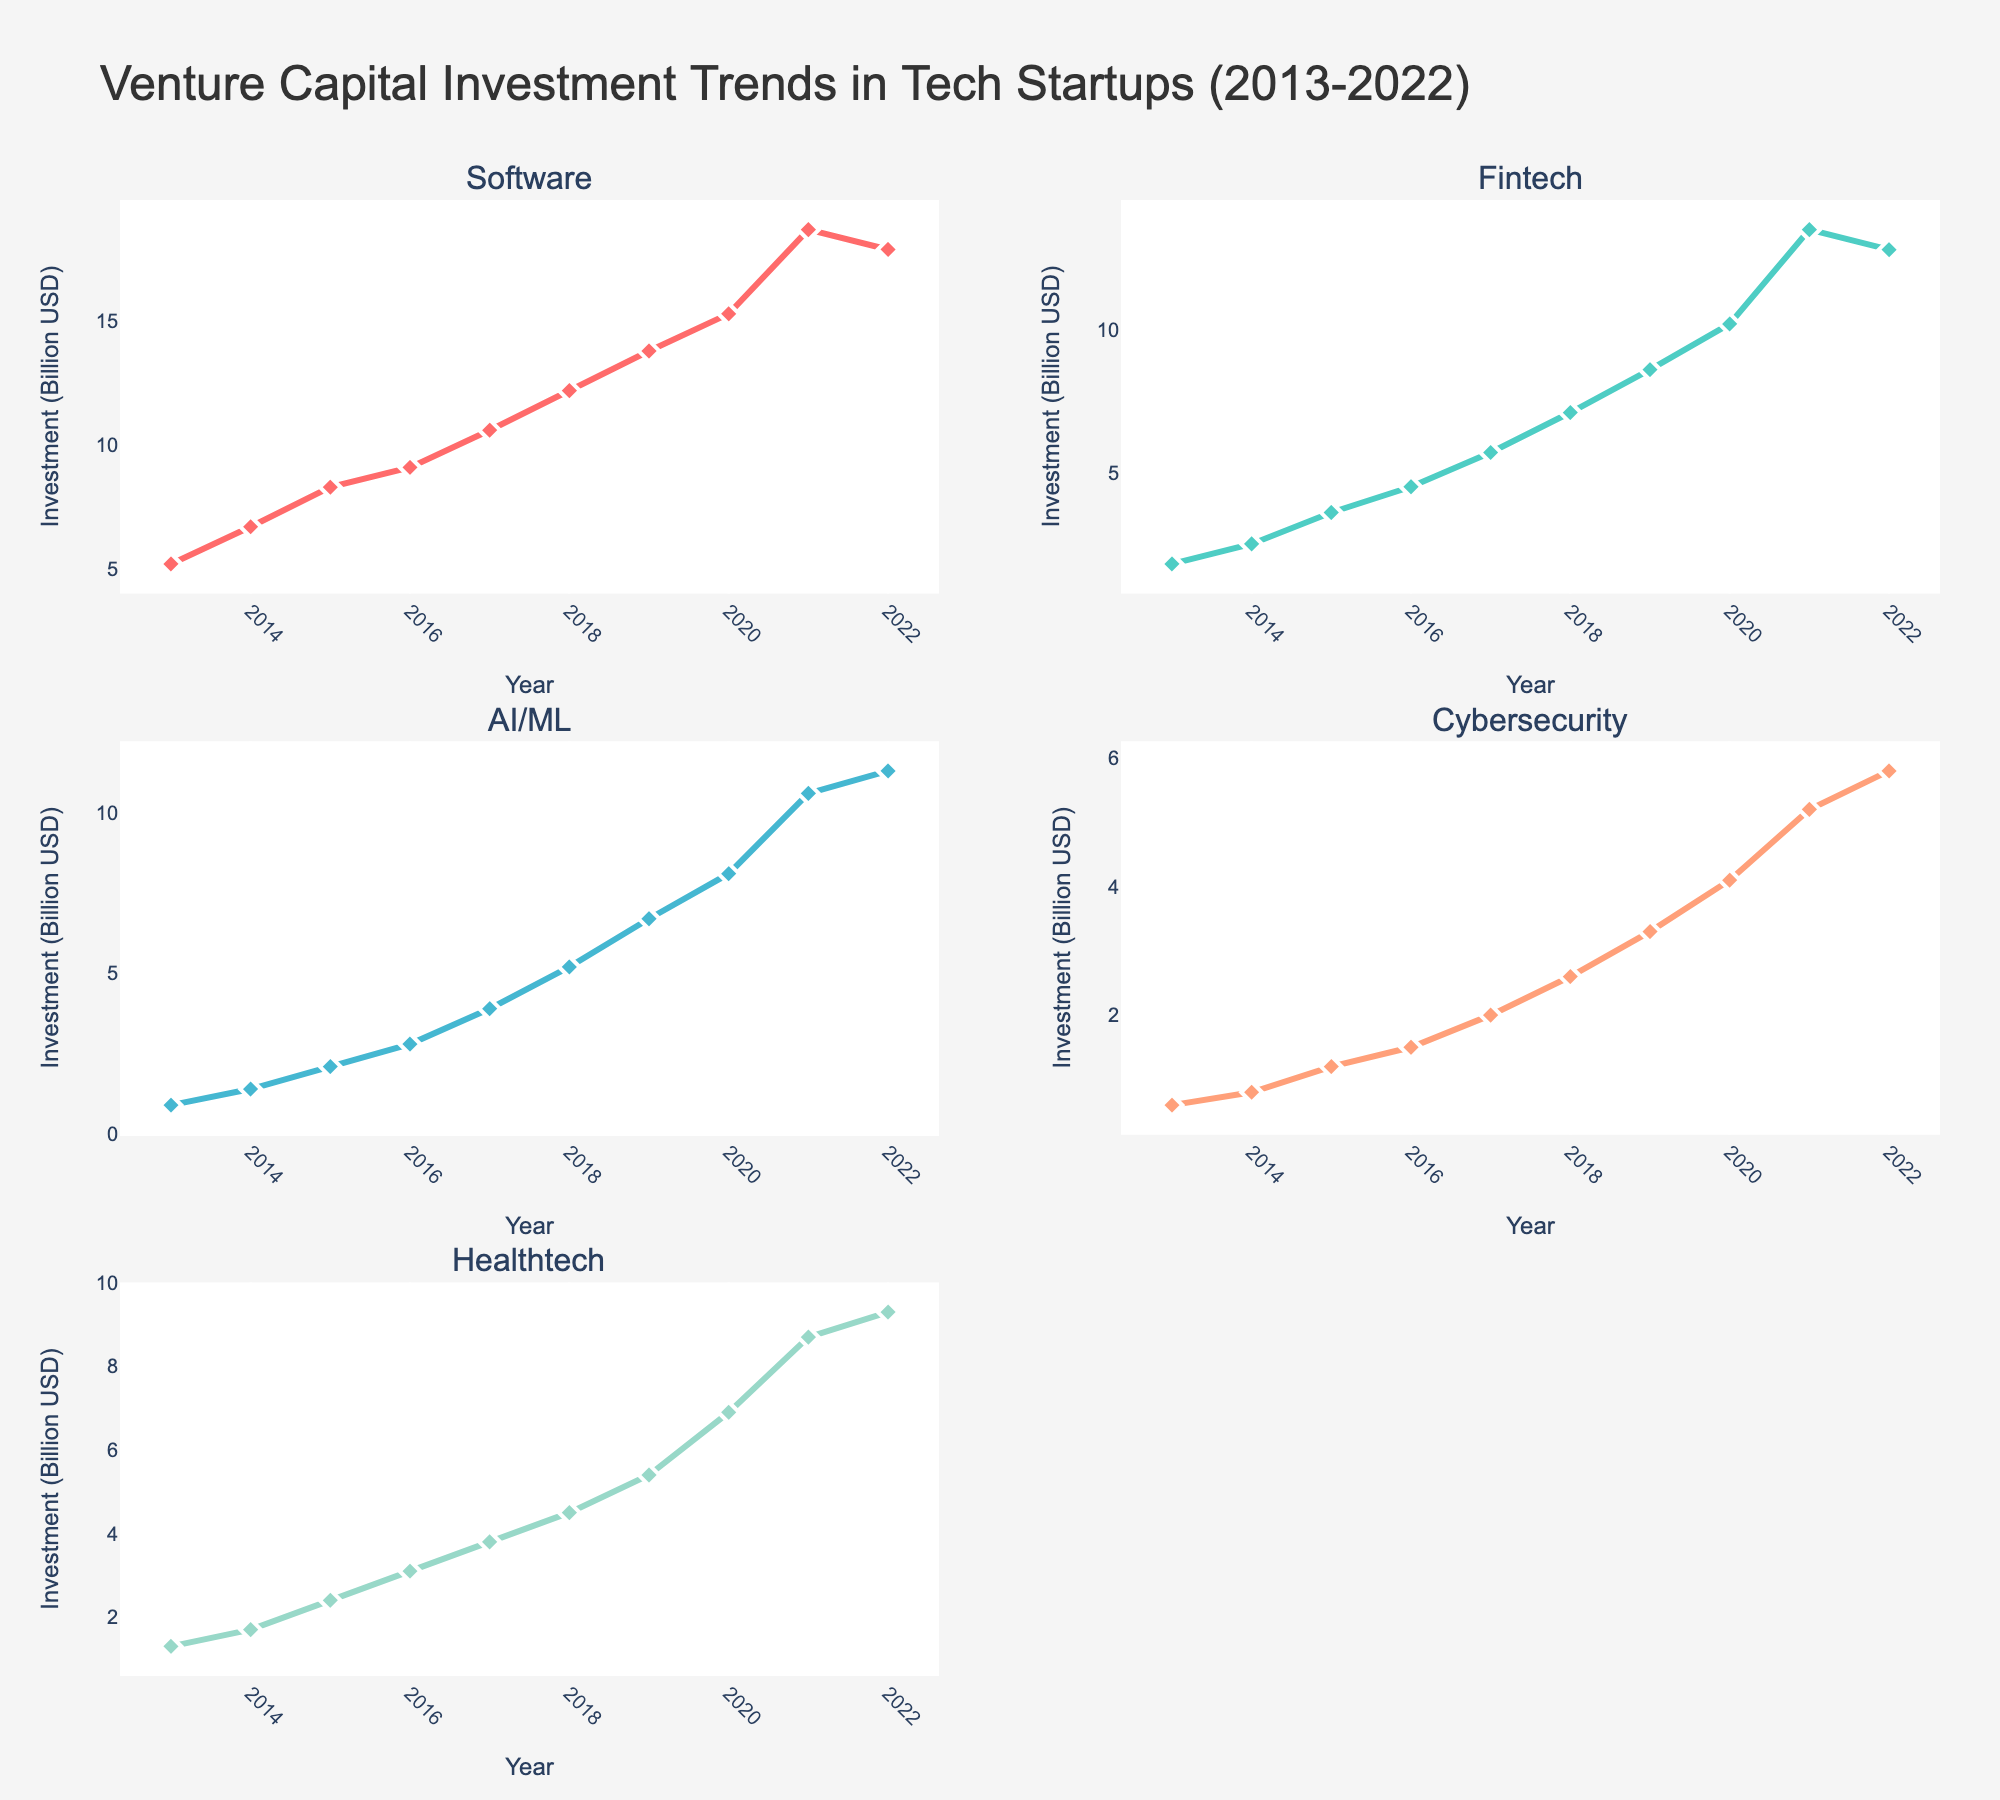Which industry saw the highest VC investment in 2022? By inspecting the 2022 values on the plots, we see that AI/ML received the highest investment at 11.3 billion USD.
Answer: AI/ML How did VC investment in Fintech change from 2018 to 2021? The investment in Fintech increased from 7.1 billion USD in 2018 to 13.5 billion USD in 2021. Calculating the difference, 13.5 - 7.1, the increase was 6.4 billion USD.
Answer: Increased by 6.4 billion USD What is the trend in VC investment in Healthtech from 2013 to 2022? The Healthtech sector shows a steady increase in VC investment from 1.3 billion USD in 2013 to 9.3 billion USD in 2022. Plot points indicate consistent year-on-year growth.
Answer: Steadily increasing Which two sectors had the closest VC investment values in 2016, and what were these values? In 2016, Healthtech and Cybersecurity had closely matched values. Healthtech had 3.1 billion USD, and Cybersecurity had 1.5 billion USD. Checking others, Software (9.1), Fintech (4.5), AI/ML (2.8) were not as close.
Answer: Healthtech (3.1) and Cybersecurity (1.5) From which year did AI/ML investments consistently exceed 5 billion USD? Checking the plots for AI/ML, we see that investment exceeded 5 billion USD starting from 2018 onwards, as it rose to 5.2 billion USD in that year and remained higher.
Answer: 2018 How much did VC investment in Cybersecurity increase from 2013 to 2020? Initial value in 2013 for Cybersecurity was 0.6 billion USD, and by 2020 it rose to 4.1 billion USD. The increase is calculated as 4.1 - 0.6 = 3.5 billion USD.
Answer: Increased by 3.5 billion USD Which sector experienced the fastest growth in VC investment between 2013 and 2021? By comparing the slopes of the lines, Software shows the steepest increase from 5.2 billion USD in 2013 to 18.7 billion USD in 2021. Other sectors' plots have more gentle slopes.
Answer: Software What is the average VC investment in Fintech from 2015 to 2018? Fintech values for 2015-2018 are 3.6, 4.5, 5.7, and 7.1 billion USD. Sum is 3.6 + 4.5 + 5.7 + 7.1 = 20.9. The average is thus 20.9 / 4 ≈ 5.225 billion USD.
Answer: 5.225 billion USD How did investments in Software and AI/ML compare in 2022? Reviewing 2022 values, Software had 17.9 billion USD while AI/ML had 11.3 billion USD. Software’s investments exceeded those of AI/ML by 17.9 - 11.3 = 6.6 billion USD.
Answer: Software exceeded AI/ML by 6.6 billion USD 